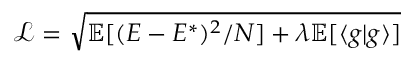Convert formula to latex. <formula><loc_0><loc_0><loc_500><loc_500>\mathcal { L } = \sqrt { \mathbb { E } [ ( E - E ^ { * } ) ^ { 2 } / N ] + \lambda \mathbb { E } [ \langle g | g \rangle ] }</formula> 